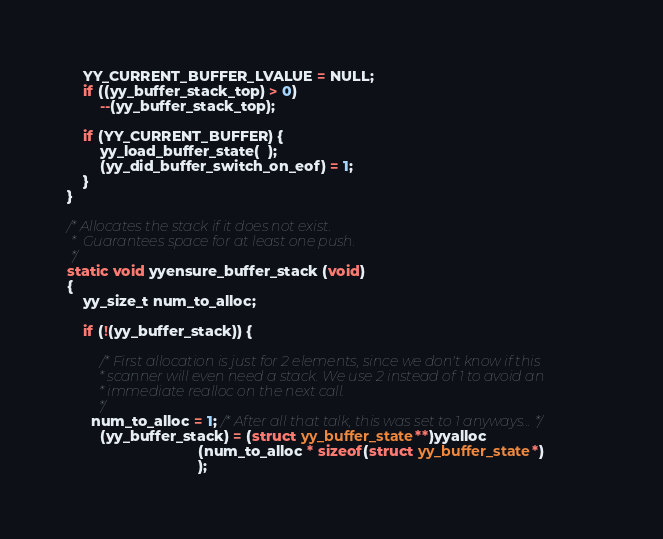<code> <loc_0><loc_0><loc_500><loc_500><_C++_>	YY_CURRENT_BUFFER_LVALUE = NULL;
	if ((yy_buffer_stack_top) > 0)
		--(yy_buffer_stack_top);

	if (YY_CURRENT_BUFFER) {
		yy_load_buffer_state(  );
		(yy_did_buffer_switch_on_eof) = 1;
	}
}

/* Allocates the stack if it does not exist.
 *  Guarantees space for at least one push.
 */
static void yyensure_buffer_stack (void)
{
	yy_size_t num_to_alloc;
    
	if (!(yy_buffer_stack)) {

		/* First allocation is just for 2 elements, since we don't know if this
		 * scanner will even need a stack. We use 2 instead of 1 to avoid an
		 * immediate realloc on the next call.
         */
      num_to_alloc = 1; /* After all that talk, this was set to 1 anyways... */
		(yy_buffer_stack) = (struct yy_buffer_state**)yyalloc
								(num_to_alloc * sizeof(struct yy_buffer_state*)
								);</code> 